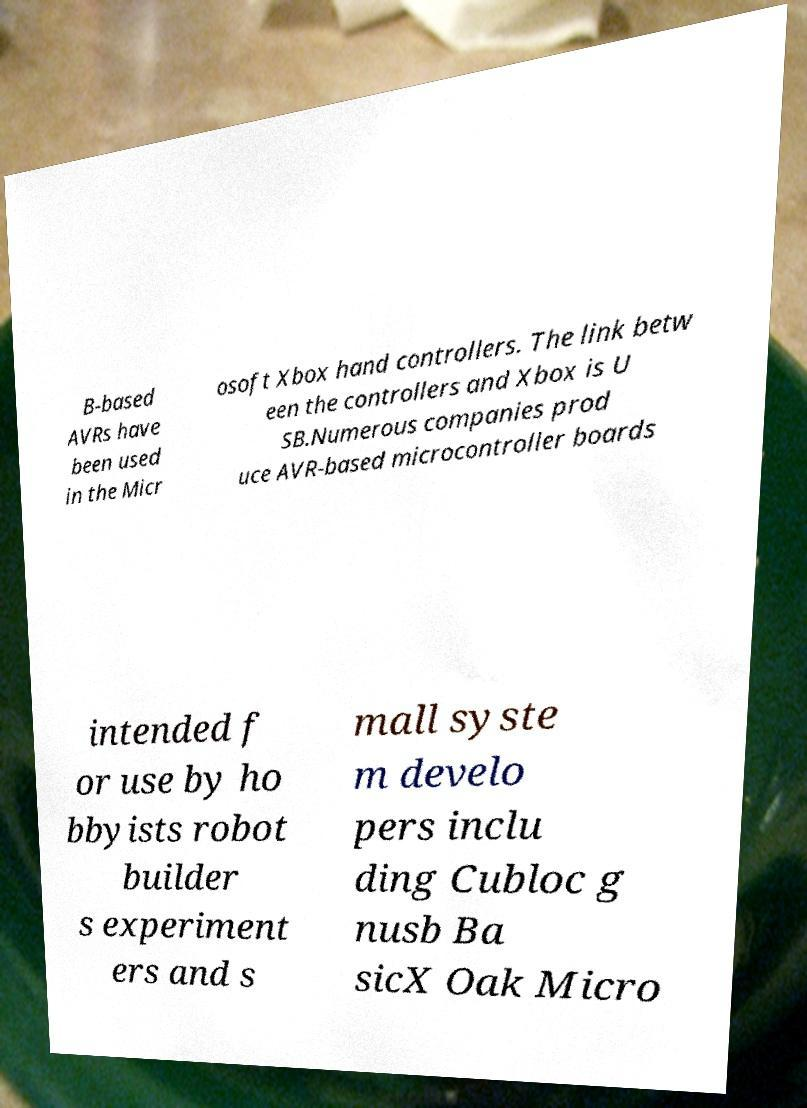Please read and relay the text visible in this image. What does it say? B-based AVRs have been used in the Micr osoft Xbox hand controllers. The link betw een the controllers and Xbox is U SB.Numerous companies prod uce AVR-based microcontroller boards intended f or use by ho bbyists robot builder s experiment ers and s mall syste m develo pers inclu ding Cubloc g nusb Ba sicX Oak Micro 